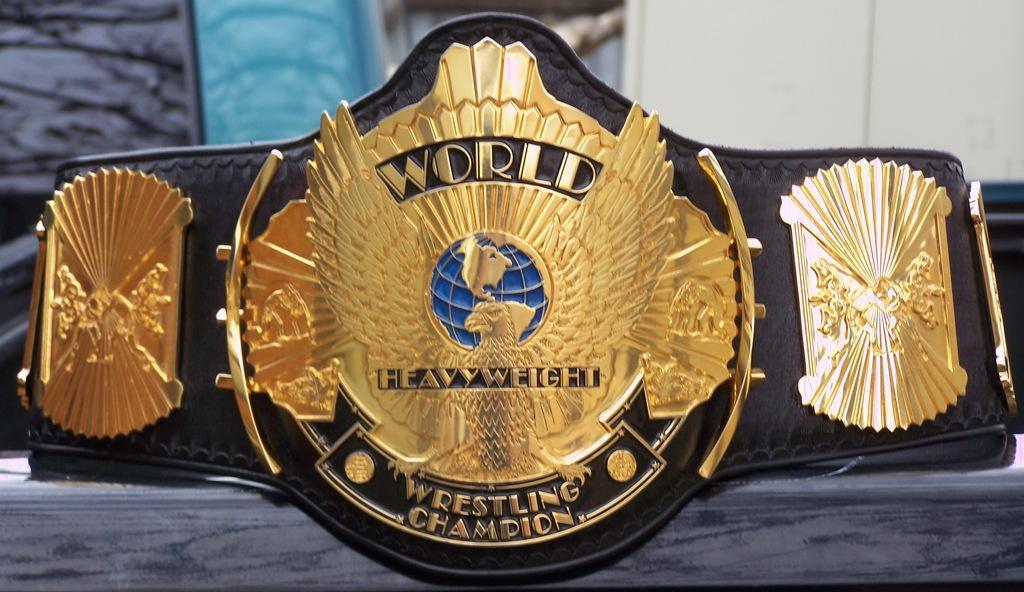In one or two sentences, can you explain what this image depicts? Here in this picture we can see a world heavyweight wrestling championship belt present on the table over there. 